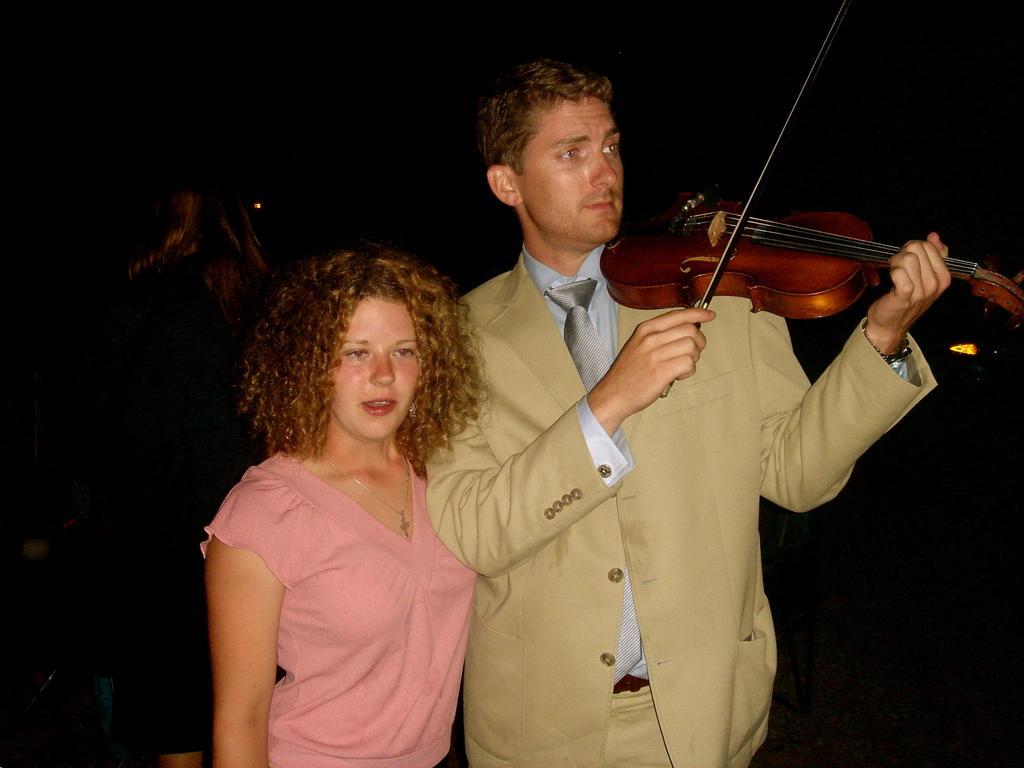Could you give a brief overview of what you see in this image? This image is clicked in a musical concert. There are two people in the middle one is women and the other is man. Man is on the right side and the woman is on the left side ,women is wearing pink colour shirt and the chain ,man is wearing sand colour blazer ,he is playing guitar. 